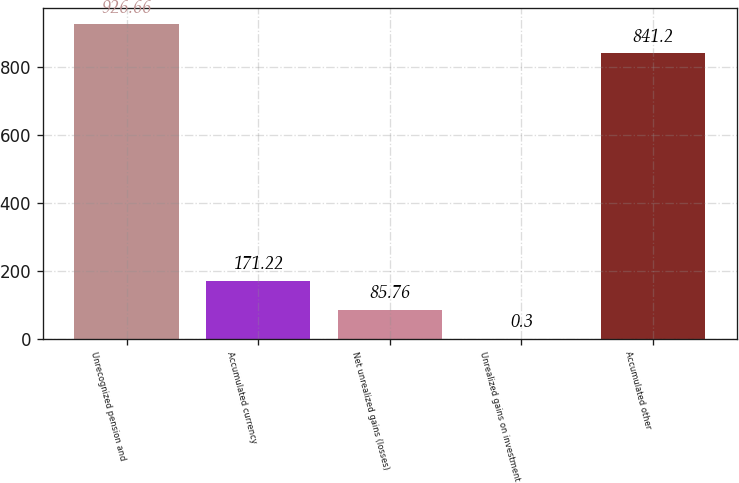Convert chart to OTSL. <chart><loc_0><loc_0><loc_500><loc_500><bar_chart><fcel>Unrecognized pension and<fcel>Accumulated currency<fcel>Net unrealized gains (losses)<fcel>Unrealized gains on investment<fcel>Accumulated other<nl><fcel>926.66<fcel>171.22<fcel>85.76<fcel>0.3<fcel>841.2<nl></chart> 